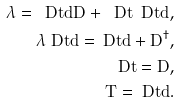Convert formula to latex. <formula><loc_0><loc_0><loc_500><loc_500>\lambda \L = \L \ D t d D + \ D t \L \ D t d , \\ \lambda \L \ D t d = \ D t d \L + \L D ^ { \dagger } , \\ \L \ D t = D \L , \\ T = \ D t \L d .</formula> 